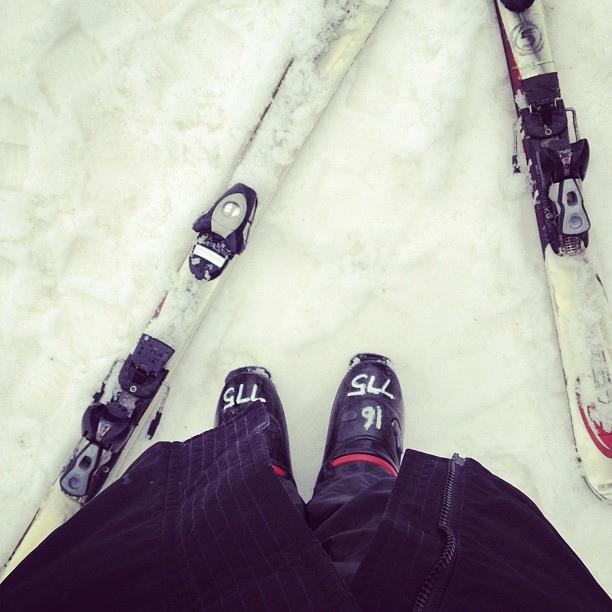What are the numbers on the person's left boot?
Concise answer only. 775. What sport was this person most recently doing?
Be succinct. Skiing. How many feet are shown?
Answer briefly. 2. 